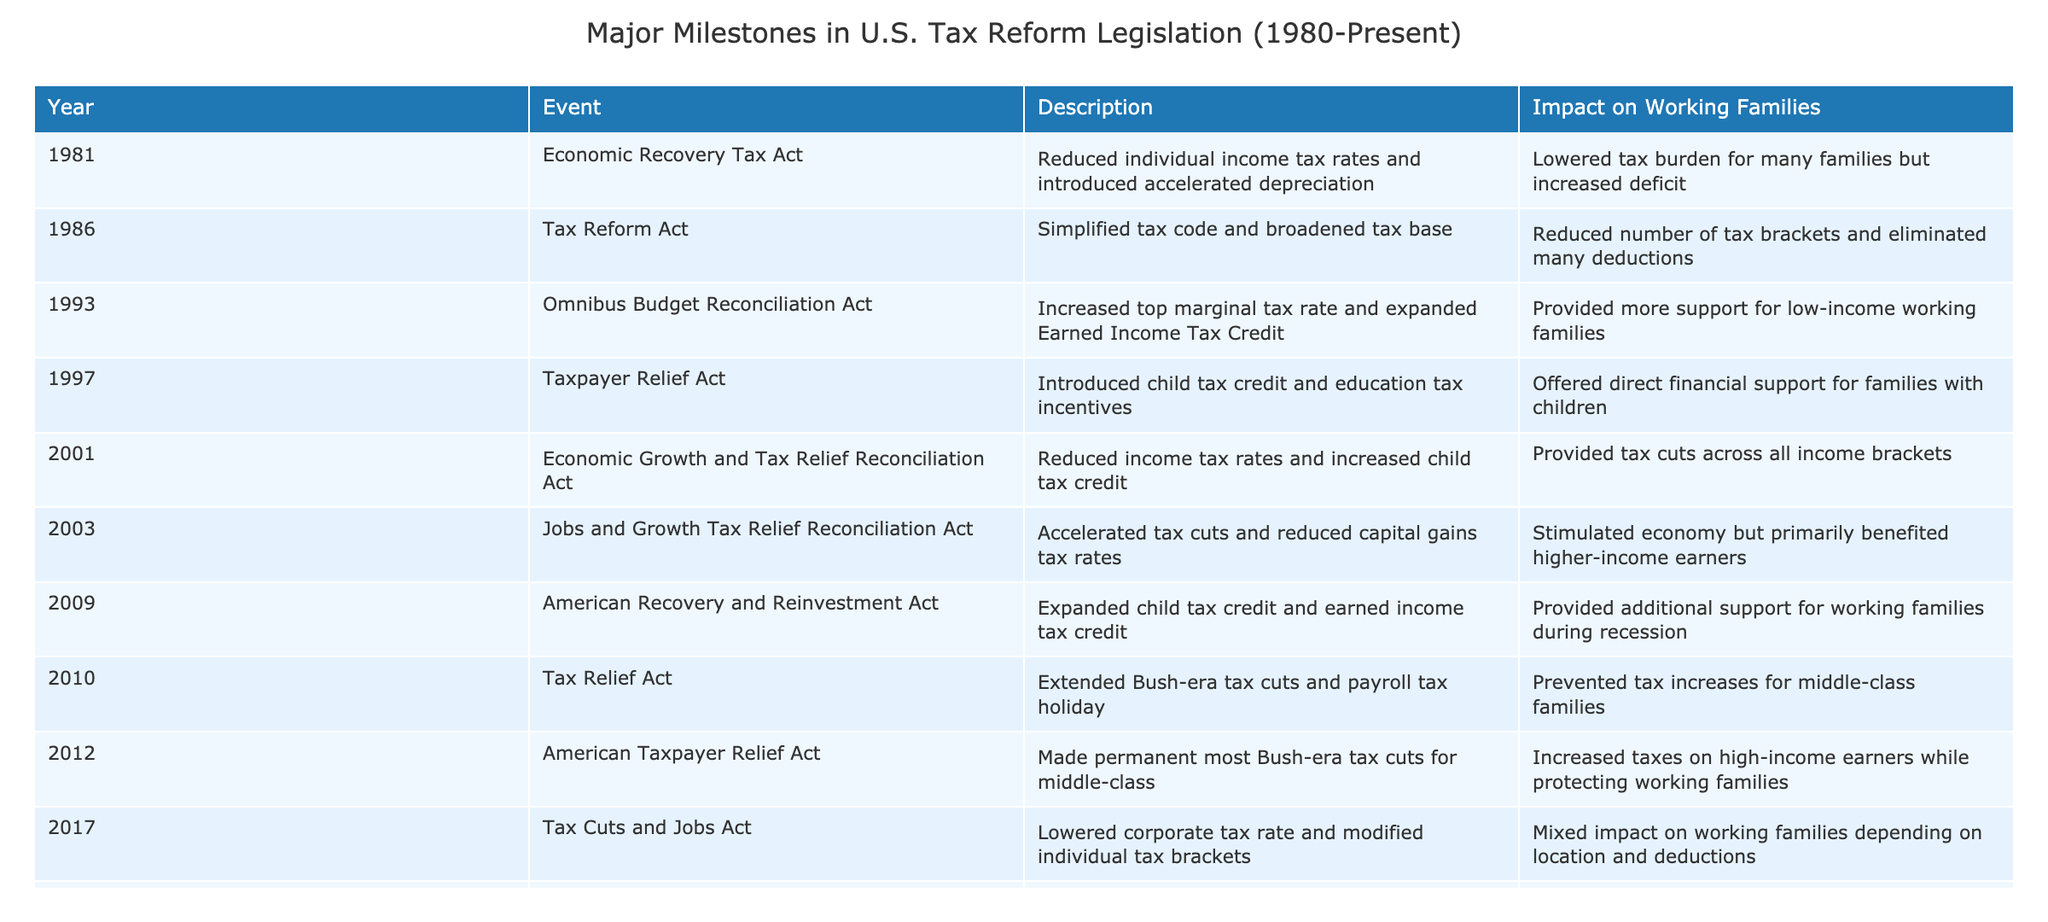What major tax reform introduced the child tax credit? The table indicates that the Taxpayer Relief Act in 1997 introduced the child tax credit, which is highlighted in the "Event" column.
Answer: Taxpayer Relief Act (1997) Which tax reform is associated with an increase in the top marginal tax rate? The Omnibus Budget Reconciliation Act of 1993 is noted in the table for increasing the top marginal tax rate, directly mentioned in the "Description" column.
Answer: Omnibus Budget Reconciliation Act (1993) What was the impact of the Tax Cuts and Jobs Act on working families? The table notes that the Tax Cuts and Jobs Act had a mixed impact on working families, depending on location and deductions mentioned in the "Impact on Working Families" column.
Answer: Mixed impact How many major tax reforms reduced individual income tax rates? By reviewing the table, the Economic Recovery Tax Act (1981), the Economic Growth and Tax Relief Reconciliation Act (2001), and the Tax Cuts and Jobs Act (2017) all reduced individual income tax rates, totaling three reforms.
Answer: Three Which tax reform was enacted during the pandemic and what support did it provide for working families? The American Rescue Plan Act of 2021 is highlighted in the table for expanding child tax credit and earned income tax credit, indicating it provided significant support during the pandemic for working families.
Answer: American Rescue Plan Act (2021) Did the Taxpayer Relief Act also provide education tax incentives? Yes, the table states that the Taxpayer Relief Act in 1997 introduced not only the child tax credit but also education tax incentives, confirming the claim.
Answer: Yes Was any tax reform focused exclusively on benefiting higher-income earners? Yes, the Jobs and Growth Tax Relief Reconciliation Act of 2003 mainly benefited higher-income earners through accelerated tax cuts and reduced capital gains tax rates, as noted in the "Impact on Working Families" column.
Answer: Yes Which tax reforms expanded either the Earned Income Tax Credit or the Child Tax Credit? The Omnibus Budget Reconciliation Act (1993), the American Recovery and Reinvestment Act (2009), and the American Rescue Plan Act (2021) all expanded these credits, as listed in the "Event" column and "Description" section.
Answer: Three reforms 